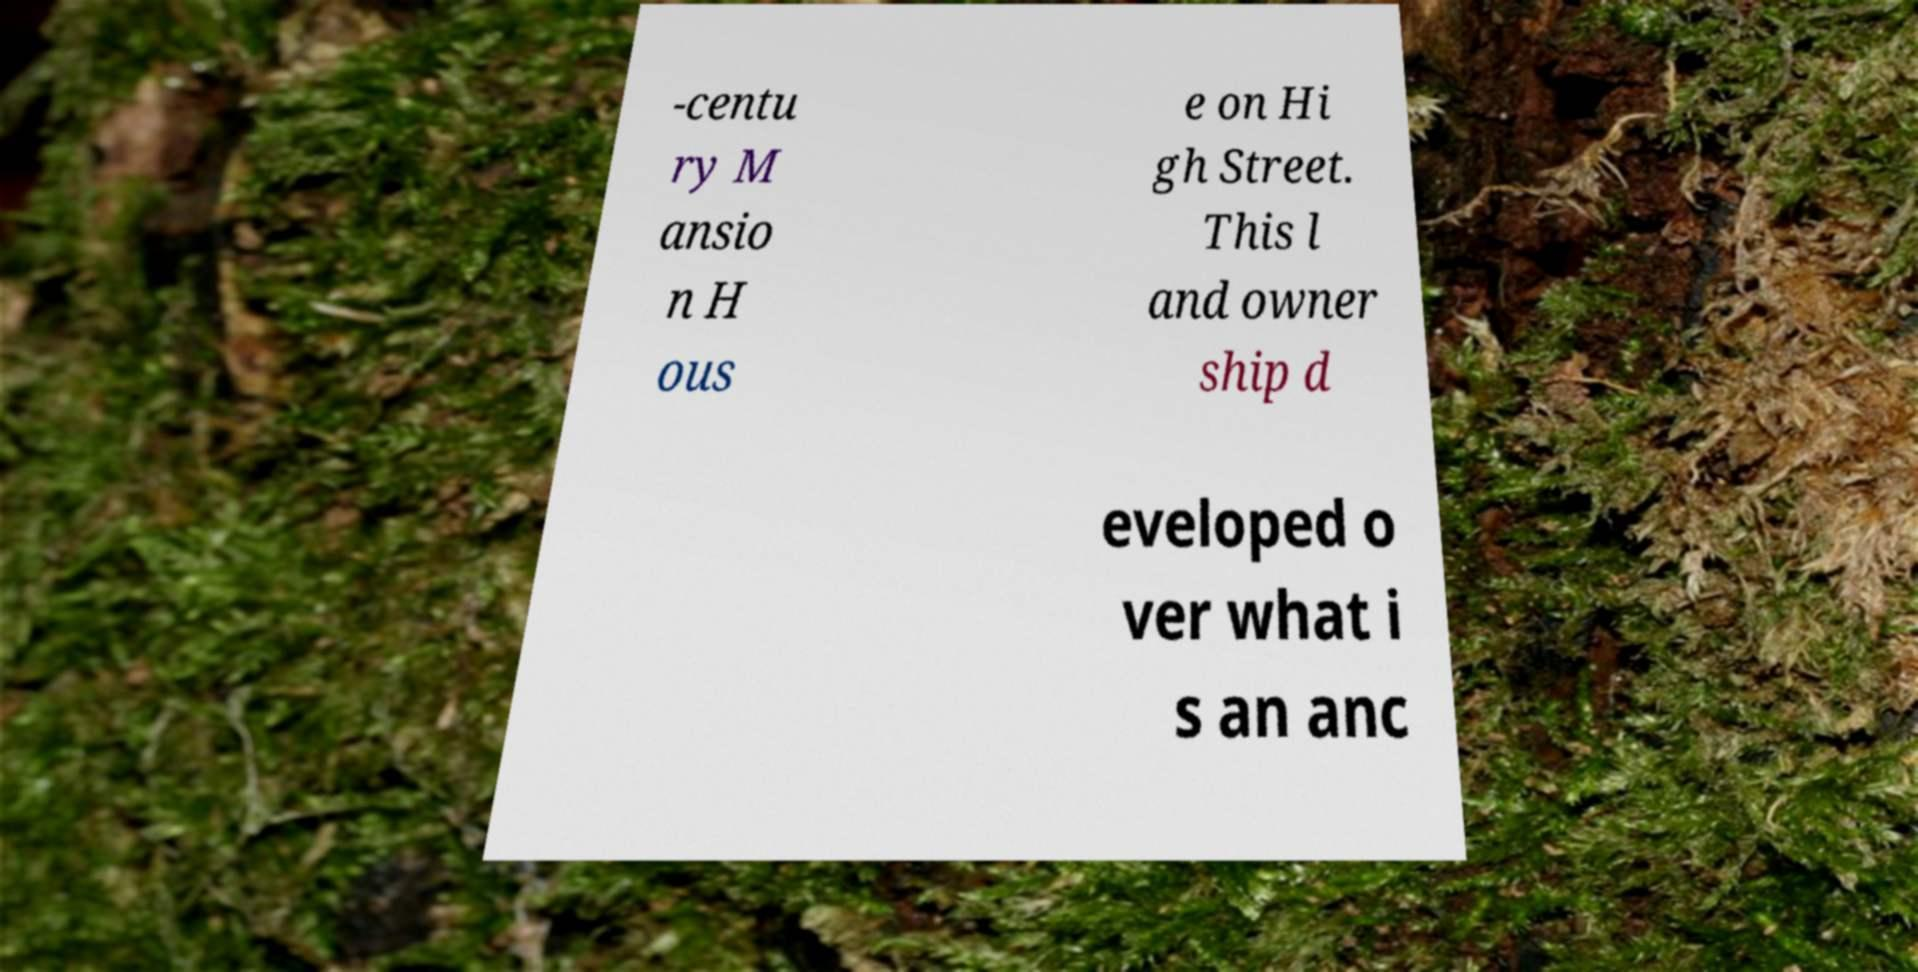There's text embedded in this image that I need extracted. Can you transcribe it verbatim? -centu ry M ansio n H ous e on Hi gh Street. This l and owner ship d eveloped o ver what i s an anc 